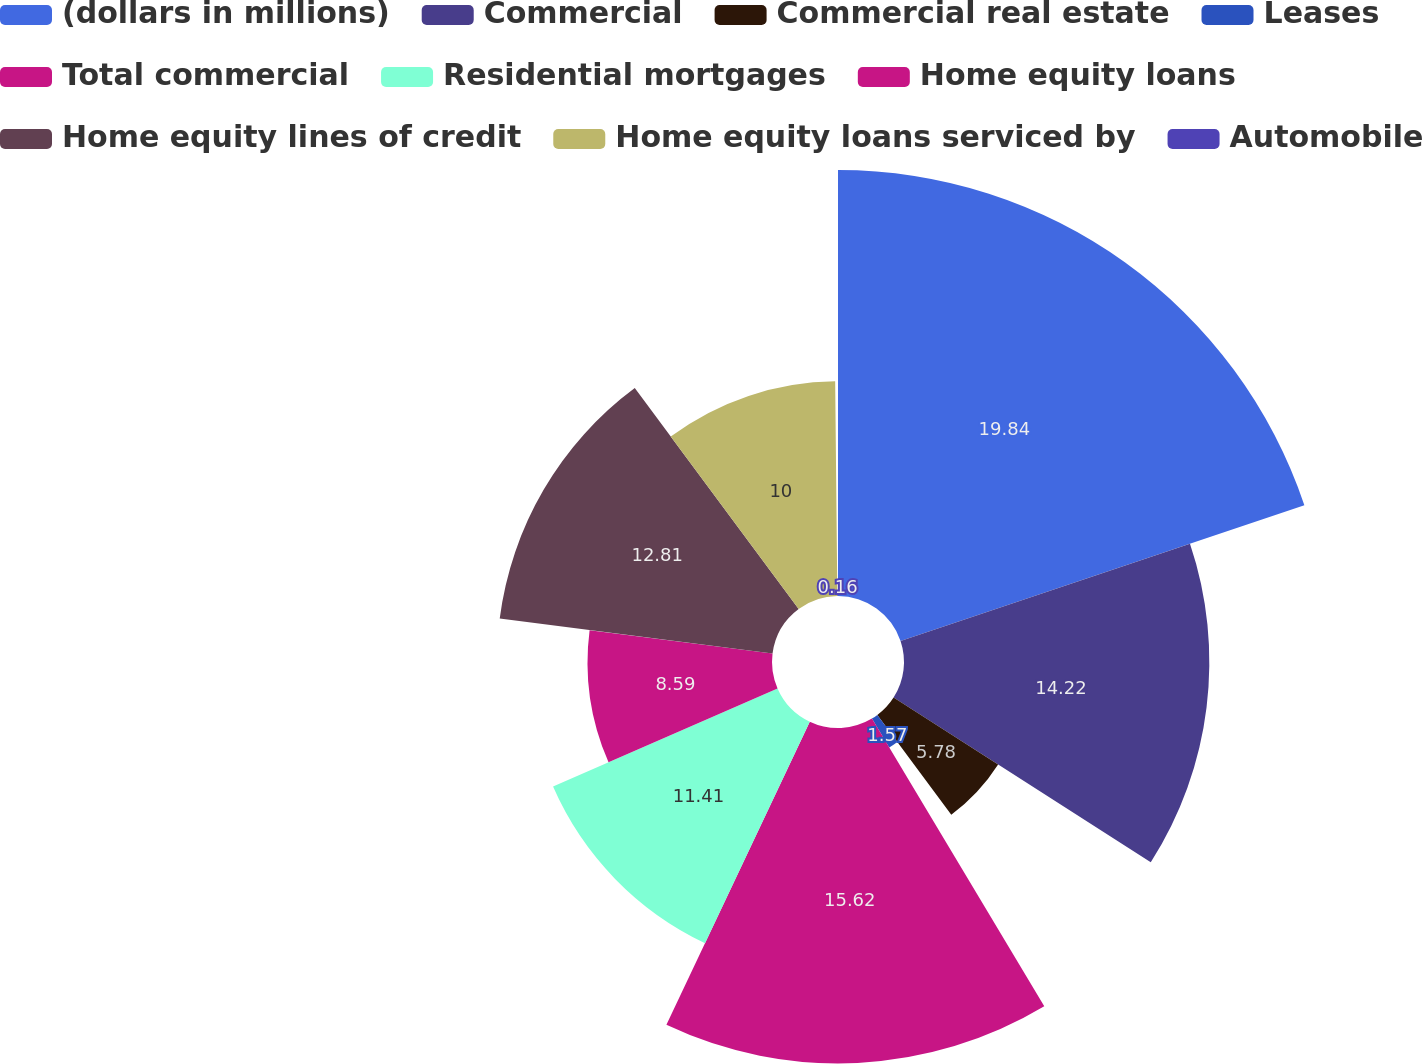Convert chart to OTSL. <chart><loc_0><loc_0><loc_500><loc_500><pie_chart><fcel>(dollars in millions)<fcel>Commercial<fcel>Commercial real estate<fcel>Leases<fcel>Total commercial<fcel>Residential mortgages<fcel>Home equity loans<fcel>Home equity lines of credit<fcel>Home equity loans serviced by<fcel>Automobile<nl><fcel>19.84%<fcel>14.22%<fcel>5.78%<fcel>1.57%<fcel>15.62%<fcel>11.41%<fcel>8.59%<fcel>12.81%<fcel>10.0%<fcel>0.16%<nl></chart> 